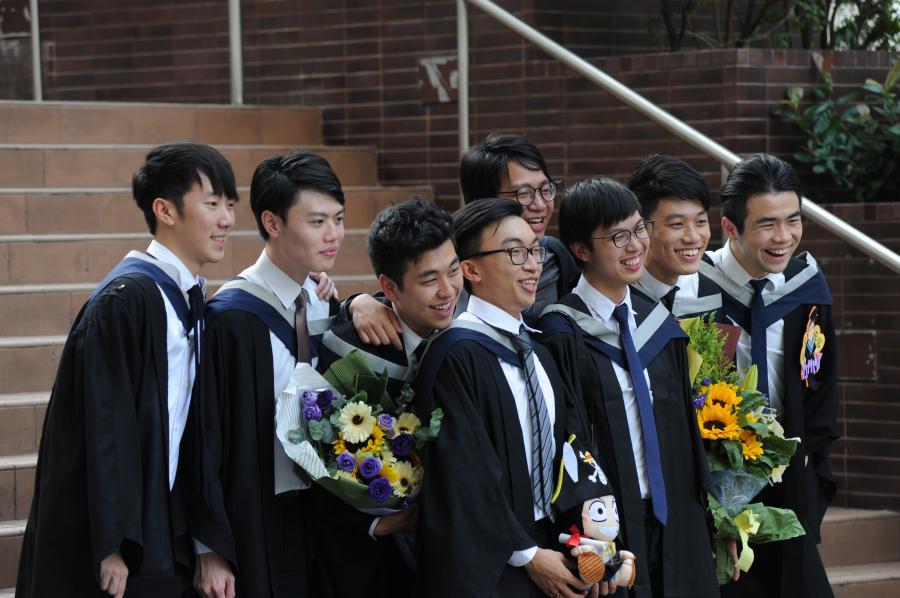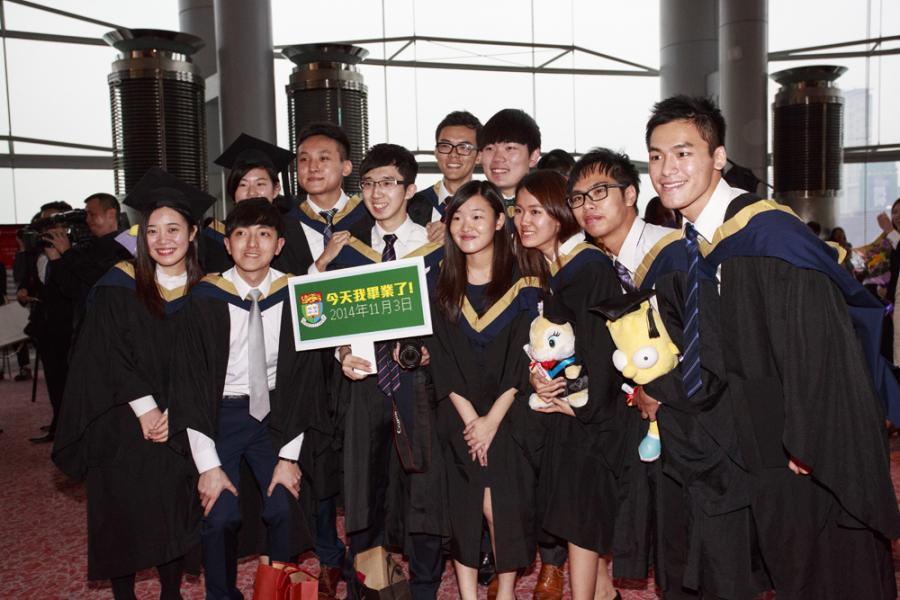The first image is the image on the left, the second image is the image on the right. Considering the images on both sides, is "Two graduates pose for a picture in one of the images." valid? Answer yes or no. No. 